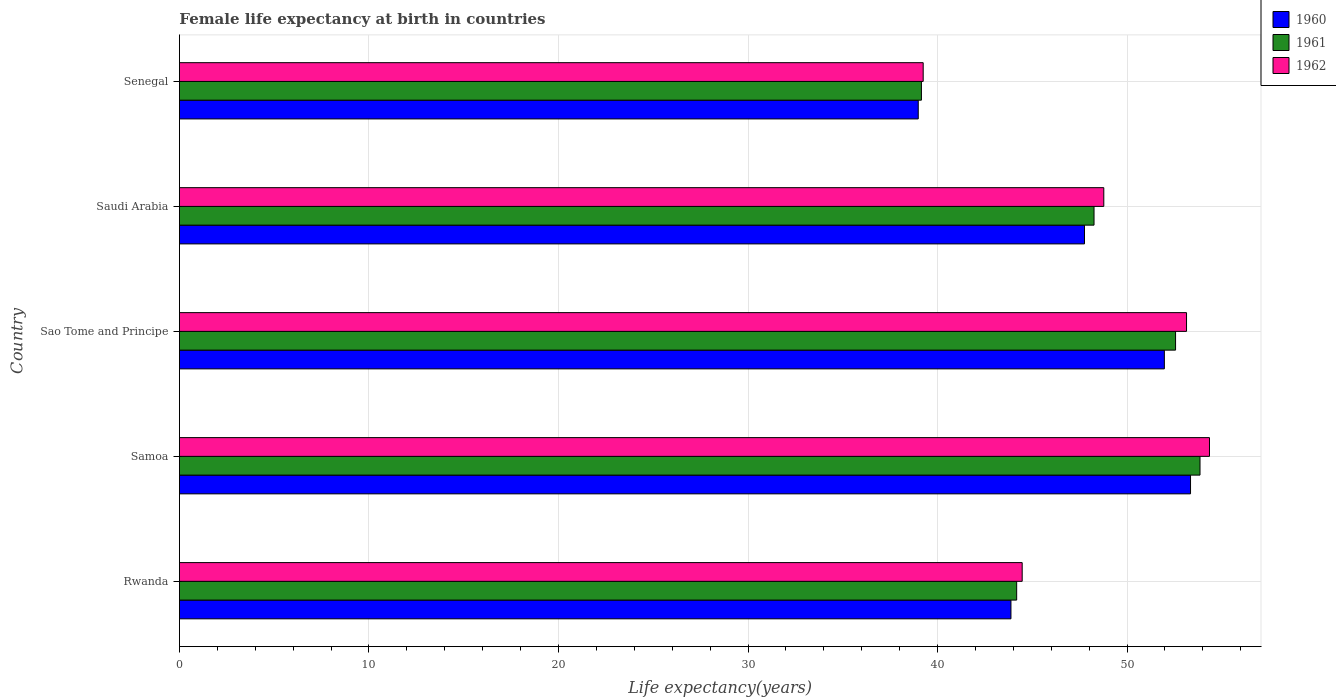How many different coloured bars are there?
Your response must be concise. 3. Are the number of bars on each tick of the Y-axis equal?
Give a very brief answer. Yes. How many bars are there on the 3rd tick from the top?
Ensure brevity in your answer.  3. What is the label of the 3rd group of bars from the top?
Your answer should be very brief. Sao Tome and Principe. In how many cases, is the number of bars for a given country not equal to the number of legend labels?
Your response must be concise. 0. What is the female life expectancy at birth in 1962 in Senegal?
Offer a terse response. 39.24. Across all countries, what is the maximum female life expectancy at birth in 1962?
Keep it short and to the point. 54.35. Across all countries, what is the minimum female life expectancy at birth in 1960?
Give a very brief answer. 38.98. In which country was the female life expectancy at birth in 1961 maximum?
Ensure brevity in your answer.  Samoa. In which country was the female life expectancy at birth in 1961 minimum?
Offer a very short reply. Senegal. What is the total female life expectancy at birth in 1960 in the graph?
Your answer should be compact. 235.93. What is the difference between the female life expectancy at birth in 1962 in Rwanda and that in Senegal?
Give a very brief answer. 5.22. What is the difference between the female life expectancy at birth in 1962 in Samoa and the female life expectancy at birth in 1961 in Sao Tome and Principe?
Your answer should be compact. 1.79. What is the average female life expectancy at birth in 1961 per country?
Give a very brief answer. 47.6. What is the difference between the female life expectancy at birth in 1962 and female life expectancy at birth in 1960 in Saudi Arabia?
Keep it short and to the point. 1.02. In how many countries, is the female life expectancy at birth in 1960 greater than 28 years?
Your answer should be compact. 5. What is the ratio of the female life expectancy at birth in 1961 in Rwanda to that in Saudi Arabia?
Provide a succinct answer. 0.92. What is the difference between the highest and the second highest female life expectancy at birth in 1961?
Provide a succinct answer. 1.29. What is the difference between the highest and the lowest female life expectancy at birth in 1960?
Provide a succinct answer. 14.37. What does the 2nd bar from the bottom in Rwanda represents?
Give a very brief answer. 1961. Is it the case that in every country, the sum of the female life expectancy at birth in 1962 and female life expectancy at birth in 1961 is greater than the female life expectancy at birth in 1960?
Offer a very short reply. Yes. How many countries are there in the graph?
Your answer should be compact. 5. Are the values on the major ticks of X-axis written in scientific E-notation?
Your response must be concise. No. Does the graph contain grids?
Keep it short and to the point. Yes. Where does the legend appear in the graph?
Your response must be concise. Top right. How are the legend labels stacked?
Offer a terse response. Vertical. What is the title of the graph?
Provide a short and direct response. Female life expectancy at birth in countries. Does "1971" appear as one of the legend labels in the graph?
Your answer should be compact. No. What is the label or title of the X-axis?
Offer a very short reply. Life expectancy(years). What is the label or title of the Y-axis?
Offer a terse response. Country. What is the Life expectancy(years) of 1960 in Rwanda?
Offer a terse response. 43.88. What is the Life expectancy(years) in 1961 in Rwanda?
Your answer should be very brief. 44.18. What is the Life expectancy(years) of 1962 in Rwanda?
Your answer should be very brief. 44.47. What is the Life expectancy(years) in 1960 in Samoa?
Your answer should be compact. 53.35. What is the Life expectancy(years) in 1961 in Samoa?
Provide a short and direct response. 53.85. What is the Life expectancy(years) of 1962 in Samoa?
Ensure brevity in your answer.  54.35. What is the Life expectancy(years) in 1960 in Sao Tome and Principe?
Keep it short and to the point. 51.97. What is the Life expectancy(years) of 1961 in Sao Tome and Principe?
Give a very brief answer. 52.56. What is the Life expectancy(years) in 1962 in Sao Tome and Principe?
Provide a short and direct response. 53.14. What is the Life expectancy(years) in 1960 in Saudi Arabia?
Provide a short and direct response. 47.76. What is the Life expectancy(years) of 1961 in Saudi Arabia?
Provide a succinct answer. 48.26. What is the Life expectancy(years) of 1962 in Saudi Arabia?
Your answer should be very brief. 48.77. What is the Life expectancy(years) in 1960 in Senegal?
Ensure brevity in your answer.  38.98. What is the Life expectancy(years) in 1961 in Senegal?
Keep it short and to the point. 39.15. What is the Life expectancy(years) in 1962 in Senegal?
Provide a short and direct response. 39.24. Across all countries, what is the maximum Life expectancy(years) of 1960?
Your response must be concise. 53.35. Across all countries, what is the maximum Life expectancy(years) of 1961?
Your answer should be compact. 53.85. Across all countries, what is the maximum Life expectancy(years) of 1962?
Make the answer very short. 54.35. Across all countries, what is the minimum Life expectancy(years) of 1960?
Keep it short and to the point. 38.98. Across all countries, what is the minimum Life expectancy(years) in 1961?
Keep it short and to the point. 39.15. Across all countries, what is the minimum Life expectancy(years) in 1962?
Give a very brief answer. 39.24. What is the total Life expectancy(years) of 1960 in the graph?
Your answer should be very brief. 235.93. What is the total Life expectancy(years) in 1961 in the graph?
Offer a terse response. 238. What is the total Life expectancy(years) in 1962 in the graph?
Give a very brief answer. 239.97. What is the difference between the Life expectancy(years) in 1960 in Rwanda and that in Samoa?
Give a very brief answer. -9.47. What is the difference between the Life expectancy(years) in 1961 in Rwanda and that in Samoa?
Your answer should be very brief. -9.67. What is the difference between the Life expectancy(years) in 1962 in Rwanda and that in Samoa?
Your answer should be compact. -9.88. What is the difference between the Life expectancy(years) in 1960 in Rwanda and that in Sao Tome and Principe?
Your answer should be compact. -8.09. What is the difference between the Life expectancy(years) of 1961 in Rwanda and that in Sao Tome and Principe?
Provide a succinct answer. -8.38. What is the difference between the Life expectancy(years) in 1962 in Rwanda and that in Sao Tome and Principe?
Offer a terse response. -8.67. What is the difference between the Life expectancy(years) in 1960 in Rwanda and that in Saudi Arabia?
Keep it short and to the point. -3.88. What is the difference between the Life expectancy(years) of 1961 in Rwanda and that in Saudi Arabia?
Offer a very short reply. -4.08. What is the difference between the Life expectancy(years) of 1962 in Rwanda and that in Saudi Arabia?
Provide a short and direct response. -4.31. What is the difference between the Life expectancy(years) of 1960 in Rwanda and that in Senegal?
Offer a terse response. 4.89. What is the difference between the Life expectancy(years) in 1961 in Rwanda and that in Senegal?
Keep it short and to the point. 5.03. What is the difference between the Life expectancy(years) of 1962 in Rwanda and that in Senegal?
Offer a terse response. 5.22. What is the difference between the Life expectancy(years) of 1960 in Samoa and that in Sao Tome and Principe?
Keep it short and to the point. 1.38. What is the difference between the Life expectancy(years) of 1961 in Samoa and that in Sao Tome and Principe?
Offer a terse response. 1.29. What is the difference between the Life expectancy(years) in 1962 in Samoa and that in Sao Tome and Principe?
Your response must be concise. 1.21. What is the difference between the Life expectancy(years) of 1960 in Samoa and that in Saudi Arabia?
Keep it short and to the point. 5.59. What is the difference between the Life expectancy(years) in 1961 in Samoa and that in Saudi Arabia?
Give a very brief answer. 5.59. What is the difference between the Life expectancy(years) in 1962 in Samoa and that in Saudi Arabia?
Offer a terse response. 5.58. What is the difference between the Life expectancy(years) of 1960 in Samoa and that in Senegal?
Your response must be concise. 14.37. What is the difference between the Life expectancy(years) of 1961 in Samoa and that in Senegal?
Give a very brief answer. 14.7. What is the difference between the Life expectancy(years) in 1962 in Samoa and that in Senegal?
Offer a terse response. 15.11. What is the difference between the Life expectancy(years) in 1960 in Sao Tome and Principe and that in Saudi Arabia?
Your response must be concise. 4.21. What is the difference between the Life expectancy(years) in 1961 in Sao Tome and Principe and that in Saudi Arabia?
Keep it short and to the point. 4.3. What is the difference between the Life expectancy(years) of 1962 in Sao Tome and Principe and that in Saudi Arabia?
Ensure brevity in your answer.  4.37. What is the difference between the Life expectancy(years) of 1960 in Sao Tome and Principe and that in Senegal?
Your answer should be compact. 12.99. What is the difference between the Life expectancy(years) of 1961 in Sao Tome and Principe and that in Senegal?
Provide a succinct answer. 13.41. What is the difference between the Life expectancy(years) in 1962 in Sao Tome and Principe and that in Senegal?
Your answer should be compact. 13.89. What is the difference between the Life expectancy(years) of 1960 in Saudi Arabia and that in Senegal?
Provide a short and direct response. 8.77. What is the difference between the Life expectancy(years) of 1961 in Saudi Arabia and that in Senegal?
Offer a very short reply. 9.11. What is the difference between the Life expectancy(years) of 1962 in Saudi Arabia and that in Senegal?
Keep it short and to the point. 9.53. What is the difference between the Life expectancy(years) of 1960 in Rwanda and the Life expectancy(years) of 1961 in Samoa?
Your answer should be compact. -9.97. What is the difference between the Life expectancy(years) of 1960 in Rwanda and the Life expectancy(years) of 1962 in Samoa?
Offer a terse response. -10.47. What is the difference between the Life expectancy(years) of 1961 in Rwanda and the Life expectancy(years) of 1962 in Samoa?
Your response must be concise. -10.17. What is the difference between the Life expectancy(years) of 1960 in Rwanda and the Life expectancy(years) of 1961 in Sao Tome and Principe?
Ensure brevity in your answer.  -8.69. What is the difference between the Life expectancy(years) in 1960 in Rwanda and the Life expectancy(years) in 1962 in Sao Tome and Principe?
Ensure brevity in your answer.  -9.26. What is the difference between the Life expectancy(years) in 1961 in Rwanda and the Life expectancy(years) in 1962 in Sao Tome and Principe?
Make the answer very short. -8.96. What is the difference between the Life expectancy(years) in 1960 in Rwanda and the Life expectancy(years) in 1961 in Saudi Arabia?
Your answer should be very brief. -4.38. What is the difference between the Life expectancy(years) in 1960 in Rwanda and the Life expectancy(years) in 1962 in Saudi Arabia?
Make the answer very short. -4.9. What is the difference between the Life expectancy(years) of 1961 in Rwanda and the Life expectancy(years) of 1962 in Saudi Arabia?
Ensure brevity in your answer.  -4.6. What is the difference between the Life expectancy(years) of 1960 in Rwanda and the Life expectancy(years) of 1961 in Senegal?
Provide a succinct answer. 4.72. What is the difference between the Life expectancy(years) of 1960 in Rwanda and the Life expectancy(years) of 1962 in Senegal?
Your answer should be very brief. 4.63. What is the difference between the Life expectancy(years) of 1961 in Rwanda and the Life expectancy(years) of 1962 in Senegal?
Make the answer very short. 4.93. What is the difference between the Life expectancy(years) in 1960 in Samoa and the Life expectancy(years) in 1961 in Sao Tome and Principe?
Ensure brevity in your answer.  0.79. What is the difference between the Life expectancy(years) in 1960 in Samoa and the Life expectancy(years) in 1962 in Sao Tome and Principe?
Your response must be concise. 0.21. What is the difference between the Life expectancy(years) in 1961 in Samoa and the Life expectancy(years) in 1962 in Sao Tome and Principe?
Provide a succinct answer. 0.71. What is the difference between the Life expectancy(years) of 1960 in Samoa and the Life expectancy(years) of 1961 in Saudi Arabia?
Provide a short and direct response. 5.09. What is the difference between the Life expectancy(years) of 1960 in Samoa and the Life expectancy(years) of 1962 in Saudi Arabia?
Offer a very short reply. 4.58. What is the difference between the Life expectancy(years) of 1961 in Samoa and the Life expectancy(years) of 1962 in Saudi Arabia?
Your response must be concise. 5.08. What is the difference between the Life expectancy(years) of 1960 in Samoa and the Life expectancy(years) of 1961 in Senegal?
Offer a terse response. 14.2. What is the difference between the Life expectancy(years) of 1960 in Samoa and the Life expectancy(years) of 1962 in Senegal?
Your answer should be very brief. 14.11. What is the difference between the Life expectancy(years) of 1961 in Samoa and the Life expectancy(years) of 1962 in Senegal?
Your answer should be compact. 14.61. What is the difference between the Life expectancy(years) in 1960 in Sao Tome and Principe and the Life expectancy(years) in 1961 in Saudi Arabia?
Offer a terse response. 3.71. What is the difference between the Life expectancy(years) of 1960 in Sao Tome and Principe and the Life expectancy(years) of 1962 in Saudi Arabia?
Your answer should be very brief. 3.2. What is the difference between the Life expectancy(years) of 1961 in Sao Tome and Principe and the Life expectancy(years) of 1962 in Saudi Arabia?
Offer a very short reply. 3.79. What is the difference between the Life expectancy(years) of 1960 in Sao Tome and Principe and the Life expectancy(years) of 1961 in Senegal?
Offer a terse response. 12.82. What is the difference between the Life expectancy(years) of 1960 in Sao Tome and Principe and the Life expectancy(years) of 1962 in Senegal?
Offer a terse response. 12.72. What is the difference between the Life expectancy(years) in 1961 in Sao Tome and Principe and the Life expectancy(years) in 1962 in Senegal?
Make the answer very short. 13.32. What is the difference between the Life expectancy(years) of 1960 in Saudi Arabia and the Life expectancy(years) of 1961 in Senegal?
Give a very brief answer. 8.6. What is the difference between the Life expectancy(years) in 1960 in Saudi Arabia and the Life expectancy(years) in 1962 in Senegal?
Provide a short and direct response. 8.51. What is the difference between the Life expectancy(years) of 1961 in Saudi Arabia and the Life expectancy(years) of 1962 in Senegal?
Make the answer very short. 9.01. What is the average Life expectancy(years) in 1960 per country?
Give a very brief answer. 47.19. What is the average Life expectancy(years) of 1961 per country?
Your response must be concise. 47.6. What is the average Life expectancy(years) in 1962 per country?
Your answer should be compact. 47.99. What is the difference between the Life expectancy(years) of 1960 and Life expectancy(years) of 1961 in Rwanda?
Provide a succinct answer. -0.3. What is the difference between the Life expectancy(years) of 1960 and Life expectancy(years) of 1962 in Rwanda?
Make the answer very short. -0.59. What is the difference between the Life expectancy(years) in 1961 and Life expectancy(years) in 1962 in Rwanda?
Your answer should be compact. -0.29. What is the difference between the Life expectancy(years) in 1960 and Life expectancy(years) in 1961 in Samoa?
Your answer should be very brief. -0.5. What is the difference between the Life expectancy(years) of 1961 and Life expectancy(years) of 1962 in Samoa?
Offer a very short reply. -0.5. What is the difference between the Life expectancy(years) in 1960 and Life expectancy(years) in 1961 in Sao Tome and Principe?
Ensure brevity in your answer.  -0.59. What is the difference between the Life expectancy(years) in 1960 and Life expectancy(years) in 1962 in Sao Tome and Principe?
Offer a very short reply. -1.17. What is the difference between the Life expectancy(years) of 1961 and Life expectancy(years) of 1962 in Sao Tome and Principe?
Provide a short and direct response. -0.58. What is the difference between the Life expectancy(years) of 1960 and Life expectancy(years) of 1961 in Saudi Arabia?
Give a very brief answer. -0.5. What is the difference between the Life expectancy(years) in 1960 and Life expectancy(years) in 1962 in Saudi Arabia?
Offer a terse response. -1.02. What is the difference between the Life expectancy(years) of 1961 and Life expectancy(years) of 1962 in Saudi Arabia?
Give a very brief answer. -0.52. What is the difference between the Life expectancy(years) of 1960 and Life expectancy(years) of 1961 in Senegal?
Give a very brief answer. -0.17. What is the difference between the Life expectancy(years) in 1960 and Life expectancy(years) in 1962 in Senegal?
Make the answer very short. -0.26. What is the difference between the Life expectancy(years) of 1961 and Life expectancy(years) of 1962 in Senegal?
Your answer should be very brief. -0.09. What is the ratio of the Life expectancy(years) of 1960 in Rwanda to that in Samoa?
Your response must be concise. 0.82. What is the ratio of the Life expectancy(years) in 1961 in Rwanda to that in Samoa?
Your response must be concise. 0.82. What is the ratio of the Life expectancy(years) in 1962 in Rwanda to that in Samoa?
Your answer should be compact. 0.82. What is the ratio of the Life expectancy(years) in 1960 in Rwanda to that in Sao Tome and Principe?
Your answer should be compact. 0.84. What is the ratio of the Life expectancy(years) of 1961 in Rwanda to that in Sao Tome and Principe?
Offer a terse response. 0.84. What is the ratio of the Life expectancy(years) of 1962 in Rwanda to that in Sao Tome and Principe?
Keep it short and to the point. 0.84. What is the ratio of the Life expectancy(years) in 1960 in Rwanda to that in Saudi Arabia?
Your answer should be very brief. 0.92. What is the ratio of the Life expectancy(years) in 1961 in Rwanda to that in Saudi Arabia?
Make the answer very short. 0.92. What is the ratio of the Life expectancy(years) in 1962 in Rwanda to that in Saudi Arabia?
Your answer should be very brief. 0.91. What is the ratio of the Life expectancy(years) in 1960 in Rwanda to that in Senegal?
Keep it short and to the point. 1.13. What is the ratio of the Life expectancy(years) of 1961 in Rwanda to that in Senegal?
Give a very brief answer. 1.13. What is the ratio of the Life expectancy(years) in 1962 in Rwanda to that in Senegal?
Your response must be concise. 1.13. What is the ratio of the Life expectancy(years) of 1960 in Samoa to that in Sao Tome and Principe?
Your answer should be compact. 1.03. What is the ratio of the Life expectancy(years) of 1961 in Samoa to that in Sao Tome and Principe?
Give a very brief answer. 1.02. What is the ratio of the Life expectancy(years) in 1962 in Samoa to that in Sao Tome and Principe?
Offer a terse response. 1.02. What is the ratio of the Life expectancy(years) of 1960 in Samoa to that in Saudi Arabia?
Your response must be concise. 1.12. What is the ratio of the Life expectancy(years) in 1961 in Samoa to that in Saudi Arabia?
Keep it short and to the point. 1.12. What is the ratio of the Life expectancy(years) in 1962 in Samoa to that in Saudi Arabia?
Offer a terse response. 1.11. What is the ratio of the Life expectancy(years) in 1960 in Samoa to that in Senegal?
Make the answer very short. 1.37. What is the ratio of the Life expectancy(years) in 1961 in Samoa to that in Senegal?
Your answer should be very brief. 1.38. What is the ratio of the Life expectancy(years) of 1962 in Samoa to that in Senegal?
Make the answer very short. 1.38. What is the ratio of the Life expectancy(years) of 1960 in Sao Tome and Principe to that in Saudi Arabia?
Offer a very short reply. 1.09. What is the ratio of the Life expectancy(years) of 1961 in Sao Tome and Principe to that in Saudi Arabia?
Keep it short and to the point. 1.09. What is the ratio of the Life expectancy(years) in 1962 in Sao Tome and Principe to that in Saudi Arabia?
Offer a very short reply. 1.09. What is the ratio of the Life expectancy(years) of 1960 in Sao Tome and Principe to that in Senegal?
Give a very brief answer. 1.33. What is the ratio of the Life expectancy(years) of 1961 in Sao Tome and Principe to that in Senegal?
Offer a terse response. 1.34. What is the ratio of the Life expectancy(years) of 1962 in Sao Tome and Principe to that in Senegal?
Offer a very short reply. 1.35. What is the ratio of the Life expectancy(years) in 1960 in Saudi Arabia to that in Senegal?
Provide a short and direct response. 1.23. What is the ratio of the Life expectancy(years) in 1961 in Saudi Arabia to that in Senegal?
Your answer should be very brief. 1.23. What is the ratio of the Life expectancy(years) in 1962 in Saudi Arabia to that in Senegal?
Make the answer very short. 1.24. What is the difference between the highest and the second highest Life expectancy(years) of 1960?
Your response must be concise. 1.38. What is the difference between the highest and the second highest Life expectancy(years) of 1961?
Your response must be concise. 1.29. What is the difference between the highest and the second highest Life expectancy(years) in 1962?
Your answer should be compact. 1.21. What is the difference between the highest and the lowest Life expectancy(years) of 1960?
Keep it short and to the point. 14.37. What is the difference between the highest and the lowest Life expectancy(years) in 1961?
Give a very brief answer. 14.7. What is the difference between the highest and the lowest Life expectancy(years) in 1962?
Offer a very short reply. 15.11. 